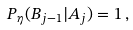<formula> <loc_0><loc_0><loc_500><loc_500>P _ { \eta } ( B _ { j - 1 } | A _ { j } ) = 1 \, ,</formula> 